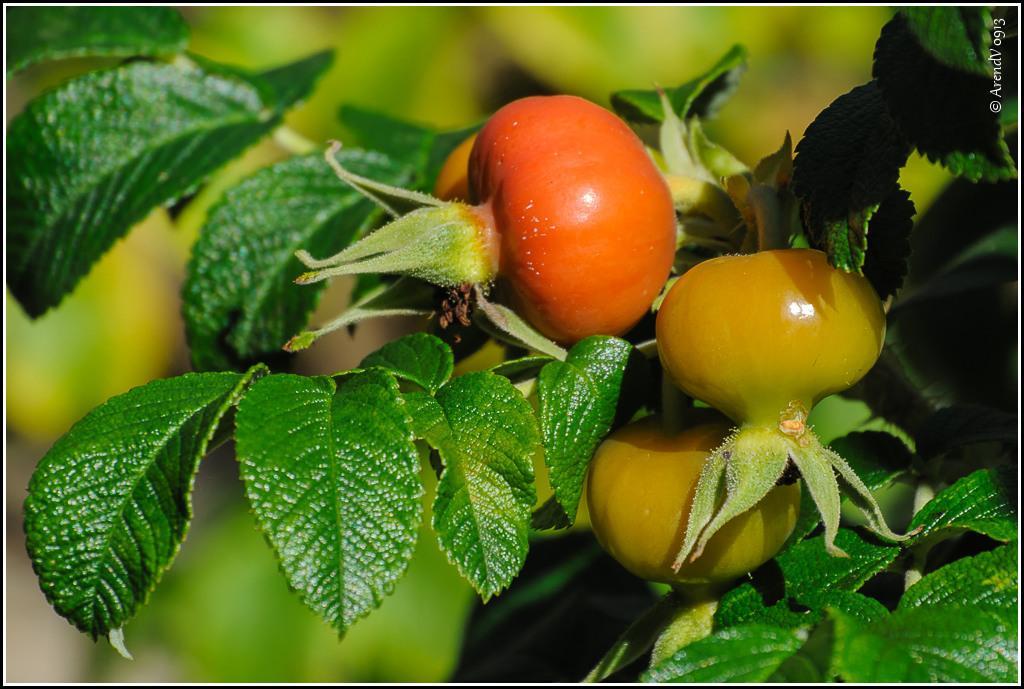In one or two sentences, can you explain what this image depicts? In this image we can see a plant with tomatoes. In the background it is blur. 